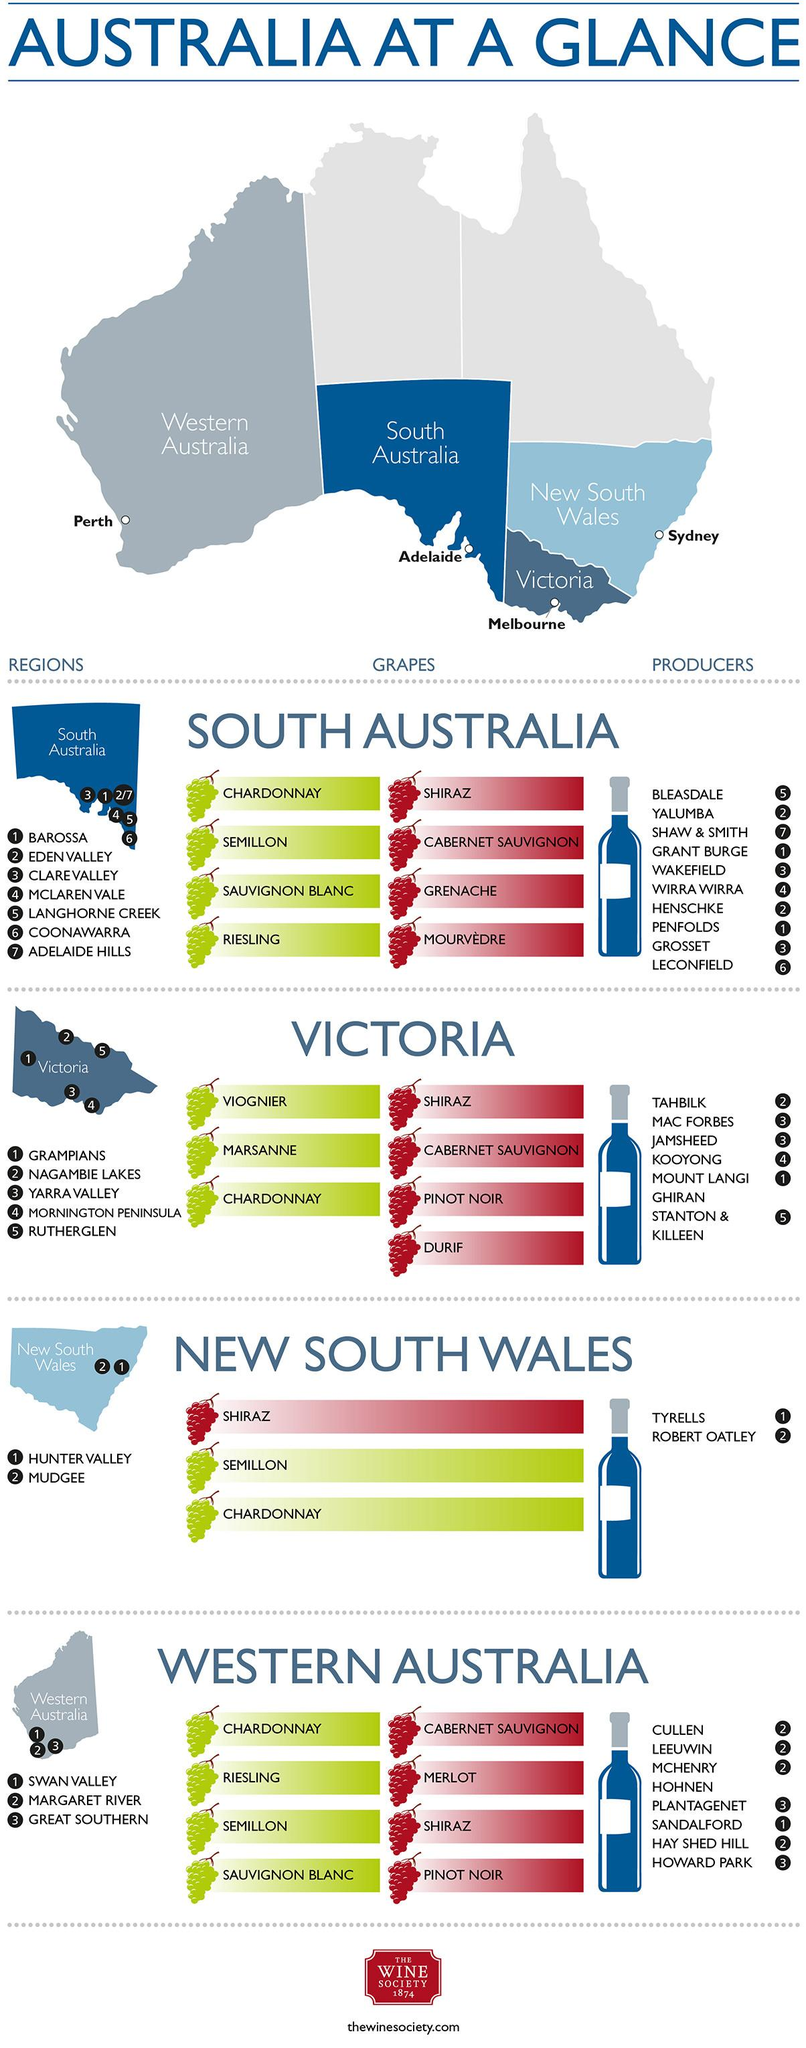Point out several critical features in this image. In the state of Victoria, Australia, the wine grape variety Viognier is prevalent. The wine grape variety Grenache is primarily found in the state of South Australia. Tyrell's Winery is a well-known winery that operates in the beautiful Hunter Valley region of New South Wales, known for producing high-quality wines that showcase the terroir of the region. Leconfield is a wine company that operates in the Coonawarra region of South Australia. ROBERT OATLEY is the wine company that operates in the Mudgee region of New South Wales. 